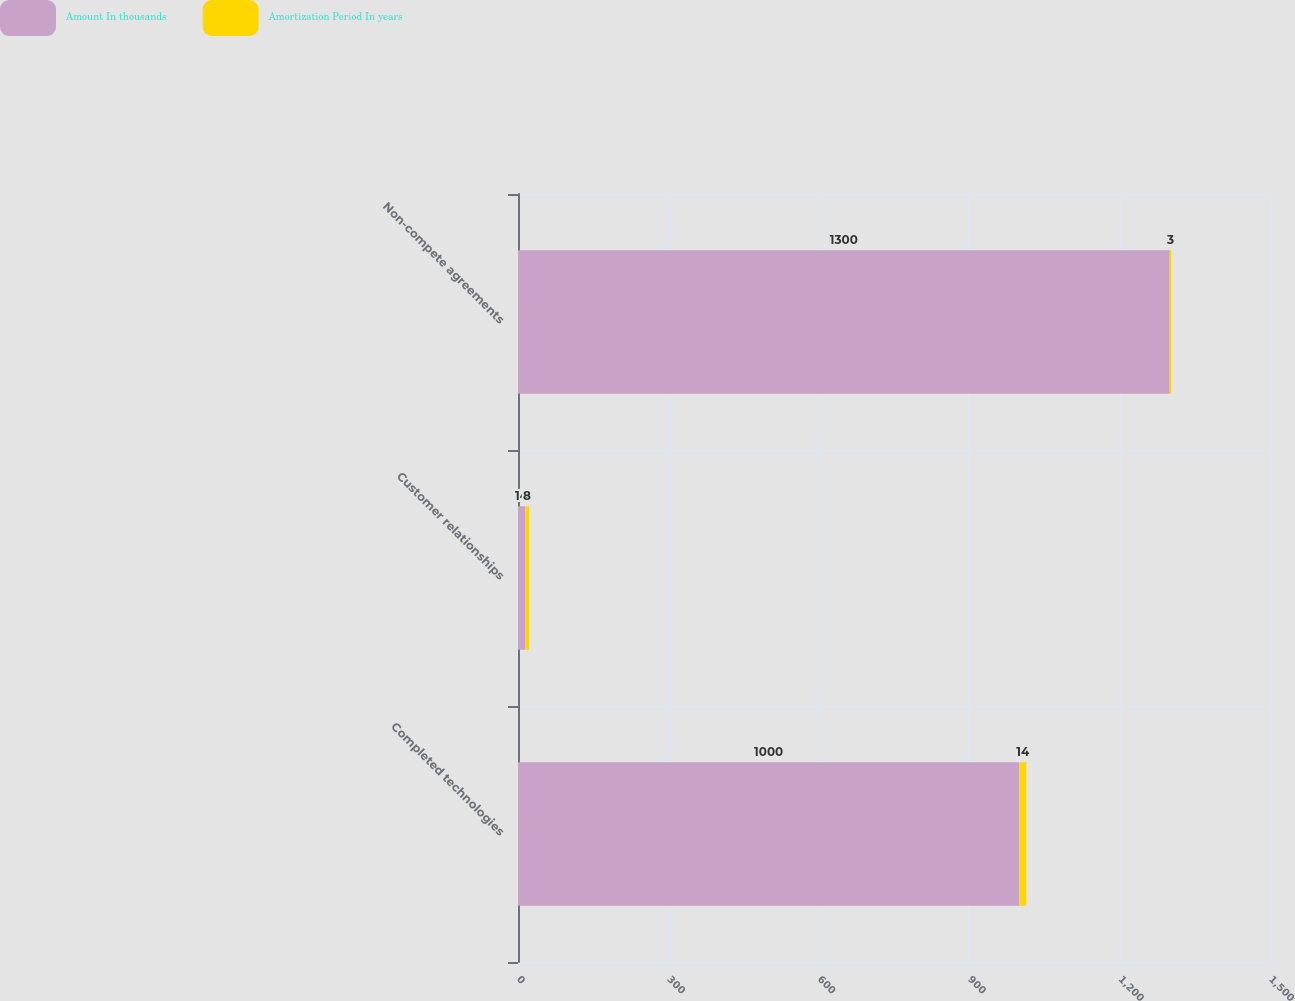<chart> <loc_0><loc_0><loc_500><loc_500><stacked_bar_chart><ecel><fcel>Completed technologies<fcel>Customer relationships<fcel>Non-compete agreements<nl><fcel>Amount In thousands<fcel>1000<fcel>14<fcel>1300<nl><fcel>Amortization Period In years<fcel>14<fcel>8<fcel>3<nl></chart> 